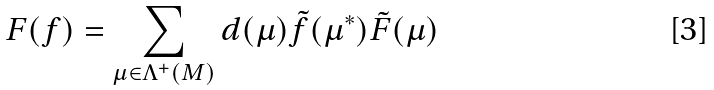<formula> <loc_0><loc_0><loc_500><loc_500>F ( f ) = \sum _ { \mu \in \Lambda ^ { + } ( M ) } d ( \mu ) \tilde { f } ( \mu ^ { * } ) \tilde { F } ( \mu ) \,</formula> 